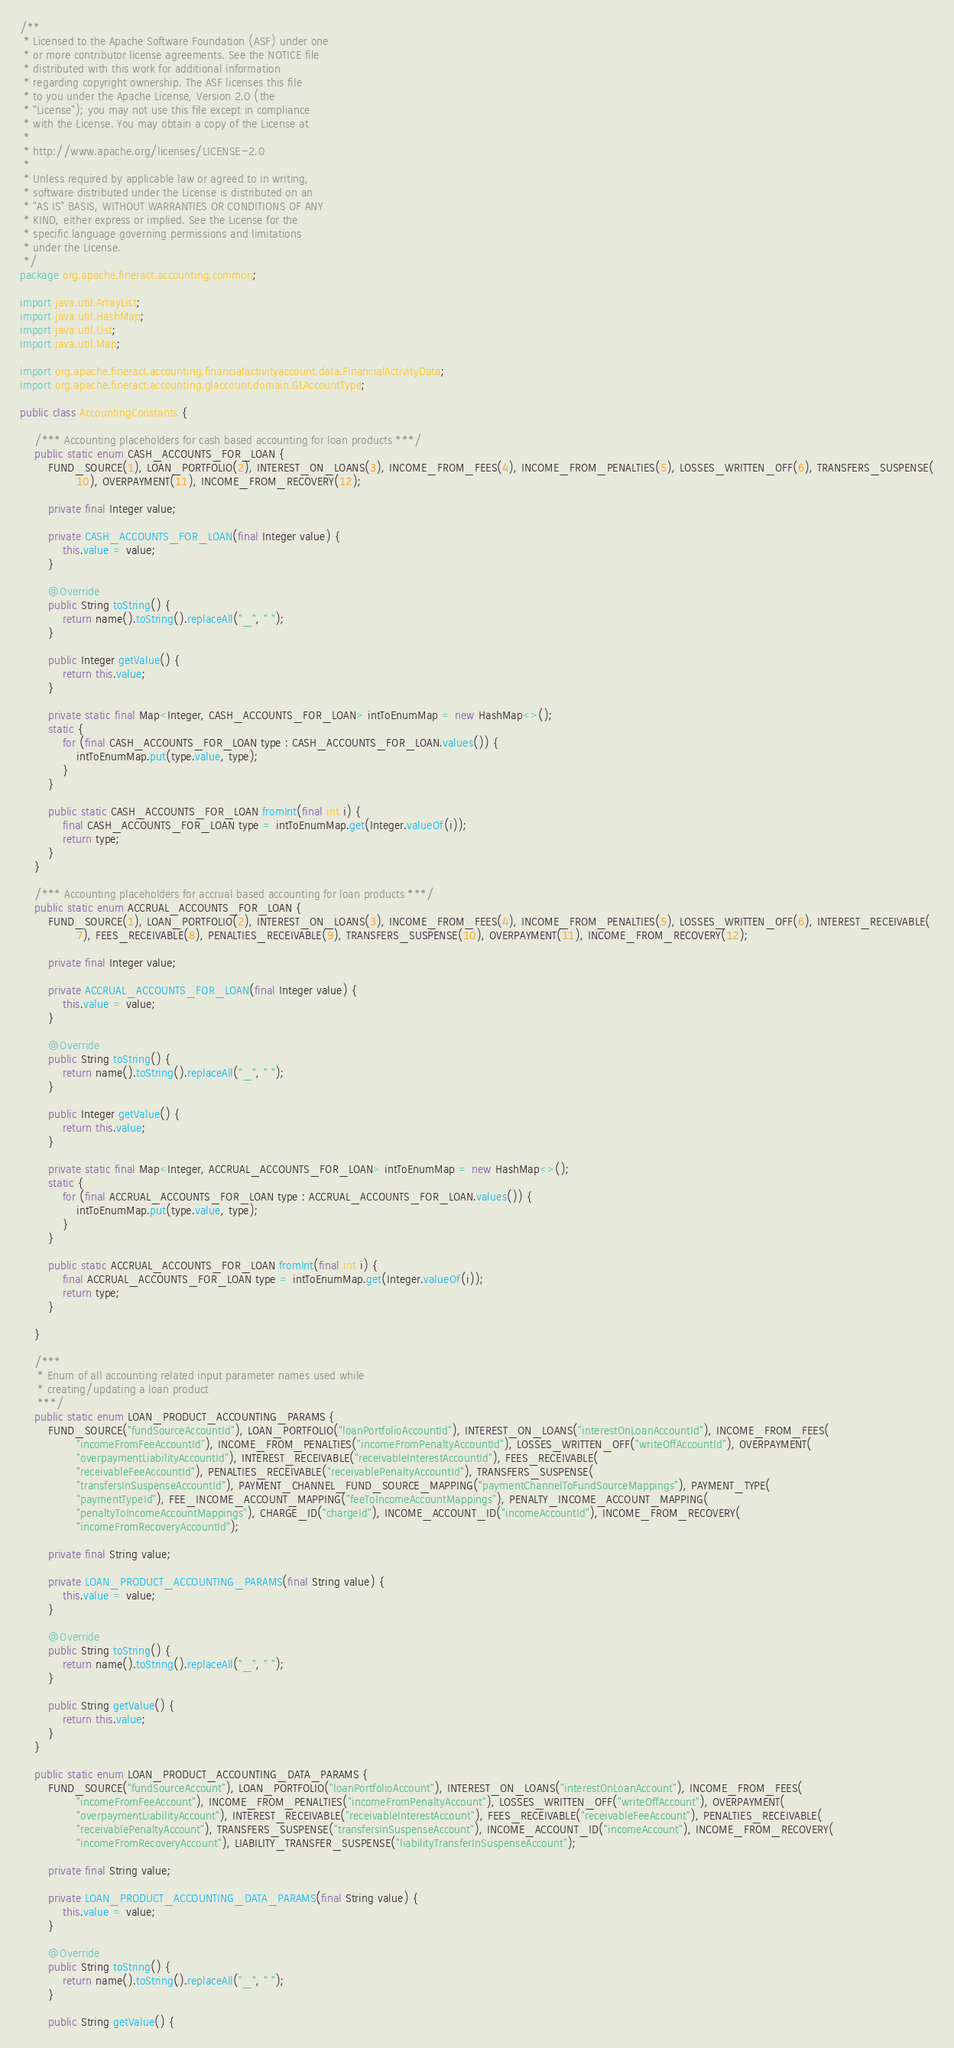Convert code to text. <code><loc_0><loc_0><loc_500><loc_500><_Java_>/**
 * Licensed to the Apache Software Foundation (ASF) under one
 * or more contributor license agreements. See the NOTICE file
 * distributed with this work for additional information
 * regarding copyright ownership. The ASF licenses this file
 * to you under the Apache License, Version 2.0 (the
 * "License"); you may not use this file except in compliance
 * with the License. You may obtain a copy of the License at
 *
 * http://www.apache.org/licenses/LICENSE-2.0
 *
 * Unless required by applicable law or agreed to in writing,
 * software distributed under the License is distributed on an
 * "AS IS" BASIS, WITHOUT WARRANTIES OR CONDITIONS OF ANY
 * KIND, either express or implied. See the License for the
 * specific language governing permissions and limitations
 * under the License.
 */
package org.apache.fineract.accounting.common;

import java.util.ArrayList;
import java.util.HashMap;
import java.util.List;
import java.util.Map;

import org.apache.fineract.accounting.financialactivityaccount.data.FinancialActivityData;
import org.apache.fineract.accounting.glaccount.domain.GLAccountType;

public class AccountingConstants {

    /*** Accounting placeholders for cash based accounting for loan products ***/
    public static enum CASH_ACCOUNTS_FOR_LOAN {
        FUND_SOURCE(1), LOAN_PORTFOLIO(2), INTEREST_ON_LOANS(3), INCOME_FROM_FEES(4), INCOME_FROM_PENALTIES(5), LOSSES_WRITTEN_OFF(6), TRANSFERS_SUSPENSE(
                10), OVERPAYMENT(11), INCOME_FROM_RECOVERY(12);

        private final Integer value;

        private CASH_ACCOUNTS_FOR_LOAN(final Integer value) {
            this.value = value;
        }

        @Override
        public String toString() {
            return name().toString().replaceAll("_", " ");
        }

        public Integer getValue() {
            return this.value;
        }

        private static final Map<Integer, CASH_ACCOUNTS_FOR_LOAN> intToEnumMap = new HashMap<>();
        static {
            for (final CASH_ACCOUNTS_FOR_LOAN type : CASH_ACCOUNTS_FOR_LOAN.values()) {
                intToEnumMap.put(type.value, type);
            }
        }

        public static CASH_ACCOUNTS_FOR_LOAN fromInt(final int i) {
            final CASH_ACCOUNTS_FOR_LOAN type = intToEnumMap.get(Integer.valueOf(i));
            return type;
        }
    }

    /*** Accounting placeholders for accrual based accounting for loan products ***/
    public static enum ACCRUAL_ACCOUNTS_FOR_LOAN {
        FUND_SOURCE(1), LOAN_PORTFOLIO(2), INTEREST_ON_LOANS(3), INCOME_FROM_FEES(4), INCOME_FROM_PENALTIES(5), LOSSES_WRITTEN_OFF(6), INTEREST_RECEIVABLE(
                7), FEES_RECEIVABLE(8), PENALTIES_RECEIVABLE(9), TRANSFERS_SUSPENSE(10), OVERPAYMENT(11), INCOME_FROM_RECOVERY(12);

        private final Integer value;

        private ACCRUAL_ACCOUNTS_FOR_LOAN(final Integer value) {
            this.value = value;
        }

        @Override
        public String toString() {
            return name().toString().replaceAll("_", " ");
        }

        public Integer getValue() {
            return this.value;
        }

        private static final Map<Integer, ACCRUAL_ACCOUNTS_FOR_LOAN> intToEnumMap = new HashMap<>();
        static {
            for (final ACCRUAL_ACCOUNTS_FOR_LOAN type : ACCRUAL_ACCOUNTS_FOR_LOAN.values()) {
                intToEnumMap.put(type.value, type);
            }
        }

        public static ACCRUAL_ACCOUNTS_FOR_LOAN fromInt(final int i) {
            final ACCRUAL_ACCOUNTS_FOR_LOAN type = intToEnumMap.get(Integer.valueOf(i));
            return type;
        }

    }

    /***
     * Enum of all accounting related input parameter names used while
     * creating/updating a loan product
     ***/
    public static enum LOAN_PRODUCT_ACCOUNTING_PARAMS {
        FUND_SOURCE("fundSourceAccountId"), LOAN_PORTFOLIO("loanPortfolioAccountId"), INTEREST_ON_LOANS("interestOnLoanAccountId"), INCOME_FROM_FEES(
                "incomeFromFeeAccountId"), INCOME_FROM_PENALTIES("incomeFromPenaltyAccountId"), LOSSES_WRITTEN_OFF("writeOffAccountId"), OVERPAYMENT(
                "overpaymentLiabilityAccountId"), INTEREST_RECEIVABLE("receivableInterestAccountId"), FEES_RECEIVABLE(
                "receivableFeeAccountId"), PENALTIES_RECEIVABLE("receivablePenaltyAccountId"), TRANSFERS_SUSPENSE(
                "transfersInSuspenseAccountId"), PAYMENT_CHANNEL_FUND_SOURCE_MAPPING("paymentChannelToFundSourceMappings"), PAYMENT_TYPE(
                "paymentTypeId"), FEE_INCOME_ACCOUNT_MAPPING("feeToIncomeAccountMappings"), PENALTY_INCOME_ACCOUNT_MAPPING(
                "penaltyToIncomeAccountMappings"), CHARGE_ID("chargeId"), INCOME_ACCOUNT_ID("incomeAccountId"), INCOME_FROM_RECOVERY(
                "incomeFromRecoveryAccountId");

        private final String value;

        private LOAN_PRODUCT_ACCOUNTING_PARAMS(final String value) {
            this.value = value;
        }

        @Override
        public String toString() {
            return name().toString().replaceAll("_", " ");
        }

        public String getValue() {
            return this.value;
        }
    }

    public static enum LOAN_PRODUCT_ACCOUNTING_DATA_PARAMS {
        FUND_SOURCE("fundSourceAccount"), LOAN_PORTFOLIO("loanPortfolioAccount"), INTEREST_ON_LOANS("interestOnLoanAccount"), INCOME_FROM_FEES(
                "incomeFromFeeAccount"), INCOME_FROM_PENALTIES("incomeFromPenaltyAccount"), LOSSES_WRITTEN_OFF("writeOffAccount"), OVERPAYMENT(
                "overpaymentLiabilityAccount"), INTEREST_RECEIVABLE("receivableInterestAccount"), FEES_RECEIVABLE("receivableFeeAccount"), PENALTIES_RECEIVABLE(
                "receivablePenaltyAccount"), TRANSFERS_SUSPENSE("transfersInSuspenseAccount"), INCOME_ACCOUNT_ID("incomeAccount"), INCOME_FROM_RECOVERY(
                "incomeFromRecoveryAccount"), LIABILITY_TRANSFER_SUSPENSE("liabilityTransferInSuspenseAccount");

        private final String value;

        private LOAN_PRODUCT_ACCOUNTING_DATA_PARAMS(final String value) {
            this.value = value;
        }

        @Override
        public String toString() {
            return name().toString().replaceAll("_", " ");
        }

        public String getValue() {</code> 